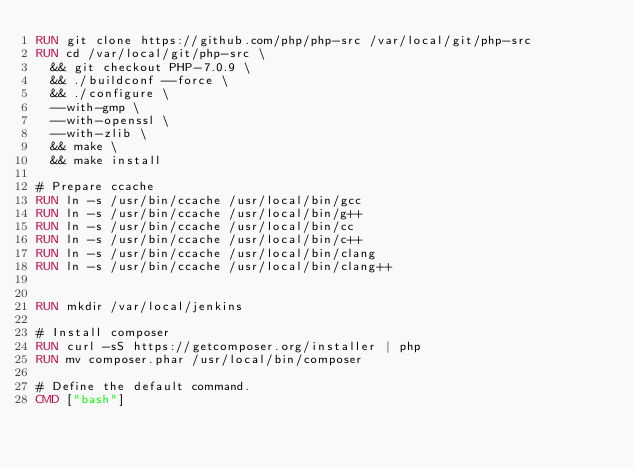<code> <loc_0><loc_0><loc_500><loc_500><_Dockerfile_>RUN git clone https://github.com/php/php-src /var/local/git/php-src
RUN cd /var/local/git/php-src \
  && git checkout PHP-7.0.9 \
  && ./buildconf --force \
  && ./configure \
  --with-gmp \
  --with-openssl \
  --with-zlib \
  && make \
  && make install

# Prepare ccache
RUN ln -s /usr/bin/ccache /usr/local/bin/gcc
RUN ln -s /usr/bin/ccache /usr/local/bin/g++
RUN ln -s /usr/bin/ccache /usr/local/bin/cc
RUN ln -s /usr/bin/ccache /usr/local/bin/c++
RUN ln -s /usr/bin/ccache /usr/local/bin/clang
RUN ln -s /usr/bin/ccache /usr/local/bin/clang++


RUN mkdir /var/local/jenkins

# Install composer
RUN curl -sS https://getcomposer.org/installer | php
RUN mv composer.phar /usr/local/bin/composer

# Define the default command.
CMD ["bash"]

</code> 